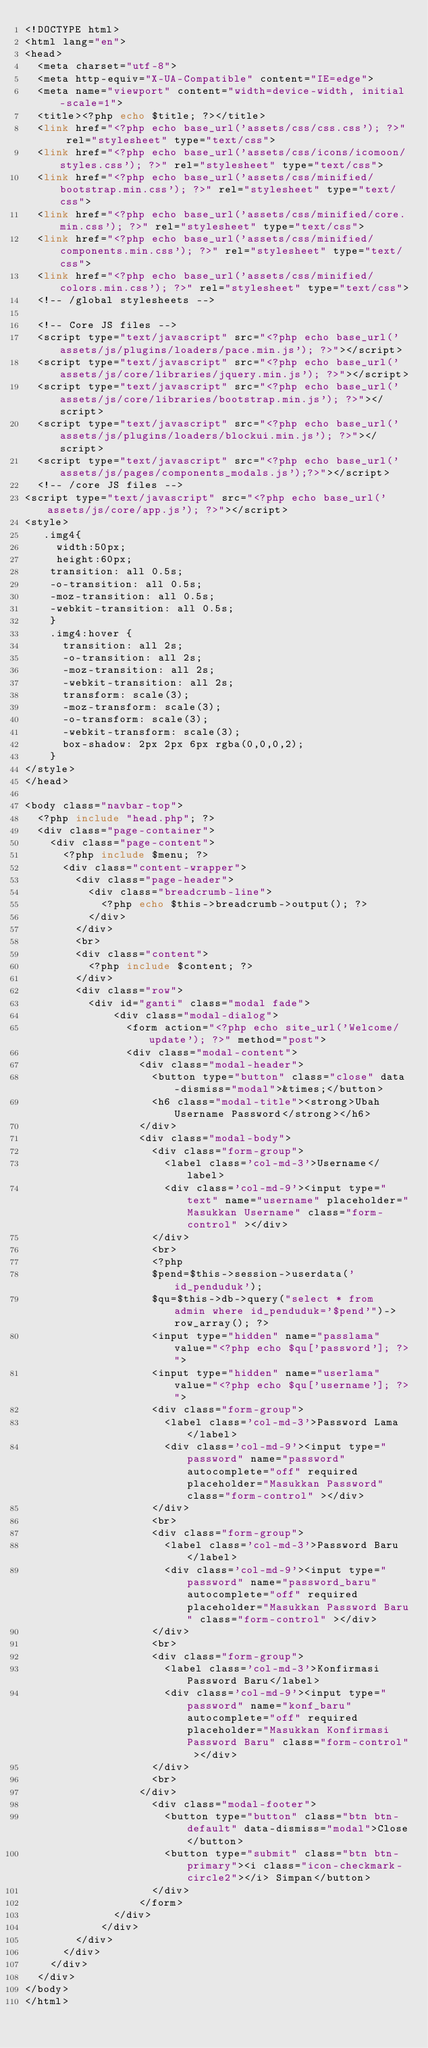Convert code to text. <code><loc_0><loc_0><loc_500><loc_500><_PHP_><!DOCTYPE html>
<html lang="en">
<head>
  <meta charset="utf-8">
  <meta http-equiv="X-UA-Compatible" content="IE=edge">
  <meta name="viewport" content="width=device-width, initial-scale=1">
  <title><?php echo $title; ?></title>
  <link href="<?php echo base_url('assets/css/css.css'); ?>" rel="stylesheet" type="text/css">
  <link href="<?php echo base_url('assets/css/icons/icomoon/styles.css'); ?>" rel="stylesheet" type="text/css">
  <link href="<?php echo base_url('assets/css/minified/bootstrap.min.css'); ?>" rel="stylesheet" type="text/css">
  <link href="<?php echo base_url('assets/css/minified/core.min.css'); ?>" rel="stylesheet" type="text/css">
  <link href="<?php echo base_url('assets/css/minified/components.min.css'); ?>" rel="stylesheet" type="text/css">
  <link href="<?php echo base_url('assets/css/minified/colors.min.css'); ?>" rel="stylesheet" type="text/css">
  <!-- /global stylesheets -->

  <!-- Core JS files -->
  <script type="text/javascript" src="<?php echo base_url('assets/js/plugins/loaders/pace.min.js'); ?>"></script>
  <script type="text/javascript" src="<?php echo base_url('assets/js/core/libraries/jquery.min.js'); ?>"></script>
  <script type="text/javascript" src="<?php echo base_url('assets/js/core/libraries/bootstrap.min.js'); ?>"></script>
  <script type="text/javascript" src="<?php echo base_url('assets/js/plugins/loaders/blockui.min.js'); ?>"></script>
  <script type="text/javascript" src="<?php echo base_url('assets/js/pages/components_modals.js');?>"></script>
  <!-- /core JS files -->
<script type="text/javascript" src="<?php echo base_url('assets/js/core/app.js'); ?>"></script>
<style>
   .img4{
     width:50px;
     height:60px;
    transition: all 0.5s;
    -o-transition: all 0.5s;
    -moz-transition: all 0.5s;
    -webkit-transition: all 0.5s;
    }
    .img4:hover {
      transition: all 2s;
      -o-transition: all 2s;
      -moz-transition: all 2s;
      -webkit-transition: all 2s;
      transform: scale(3);
      -moz-transform: scale(3);
      -o-transform: scale(3);
      -webkit-transform: scale(3);
      box-shadow: 2px 2px 6px rgba(0,0,0,2);
    }
</style>
</head>

<body class="navbar-top">
  <?php include "head.php"; ?>
  <div class="page-container">
    <div class="page-content">
      <?php include $menu; ?>
      <div class="content-wrapper">
        <div class="page-header">
          <div class="breadcrumb-line">
            <?php echo $this->breadcrumb->output(); ?>
          </div>
        </div>
        <br>
        <div class="content">
          <?php include $content; ?>
        </div>
        <div class="row">
          <div id="ganti" class="modal fade">
              <div class="modal-dialog">
                <form action="<?php echo site_url('Welcome/update'); ?>" method="post">
                <div class="modal-content">
                  <div class="modal-header">
                    <button type="button" class="close" data-dismiss="modal">&times;</button>
                    <h6 class="modal-title"><strong>Ubah Username Password</strong></h6>
                  </div>
                  <div class="modal-body">
                    <div class="form-group">
                      <label class='col-md-3'>Username</label>
                      <div class='col-md-9'><input type="text" name="username" placeholder="Masukkan Username" class="form-control" ></div>
                    </div>
                    <br>
                    <?php 
                    $pend=$this->session->userdata('id_penduduk');
                    $qu=$this->db->query("select * from admin where id_penduduk='$pend'")->row_array(); ?>
                    <input type="hidden" name="passlama" value="<?php echo $qu['password']; ?>">
                    <input type="hidden" name="userlama" value="<?php echo $qu['username']; ?>">
                    <div class="form-group">
                      <label class='col-md-3'>Password Lama</label>
                      <div class='col-md-9'><input type="password" name="password" autocomplete="off" required placeholder="Masukkan Password" class="form-control" ></div>
                    </div>
                    <br>
                    <div class="form-group">
                      <label class='col-md-3'>Password Baru</label>
                      <div class='col-md-9'><input type="password" name="password_baru" autocomplete="off" required placeholder="Masukkan Password Baru" class="form-control" ></div>
                    </div>
                    <br>
                    <div class="form-group">
                      <label class='col-md-3'>Konfirmasi Password Baru</label>
                      <div class='col-md-9'><input type="password" name="konf_baru" autocomplete="off" required placeholder="Masukkan Konfirmasi Password Baru" class="form-control" ></div>
                    </div>
                    <br>
                  </div>
                    <div class="modal-footer">
                      <button type="button" class="btn btn-default" data-dismiss="modal">Close</button>
                      <button type="submit" class="btn btn-primary"><i class="icon-checkmark-circle2"></i> Simpan</button>
                    </div>
                  </form>
              </div>
            </div>
        </div>
      </div>
    </div>
  </div>
</body>
</html></code> 